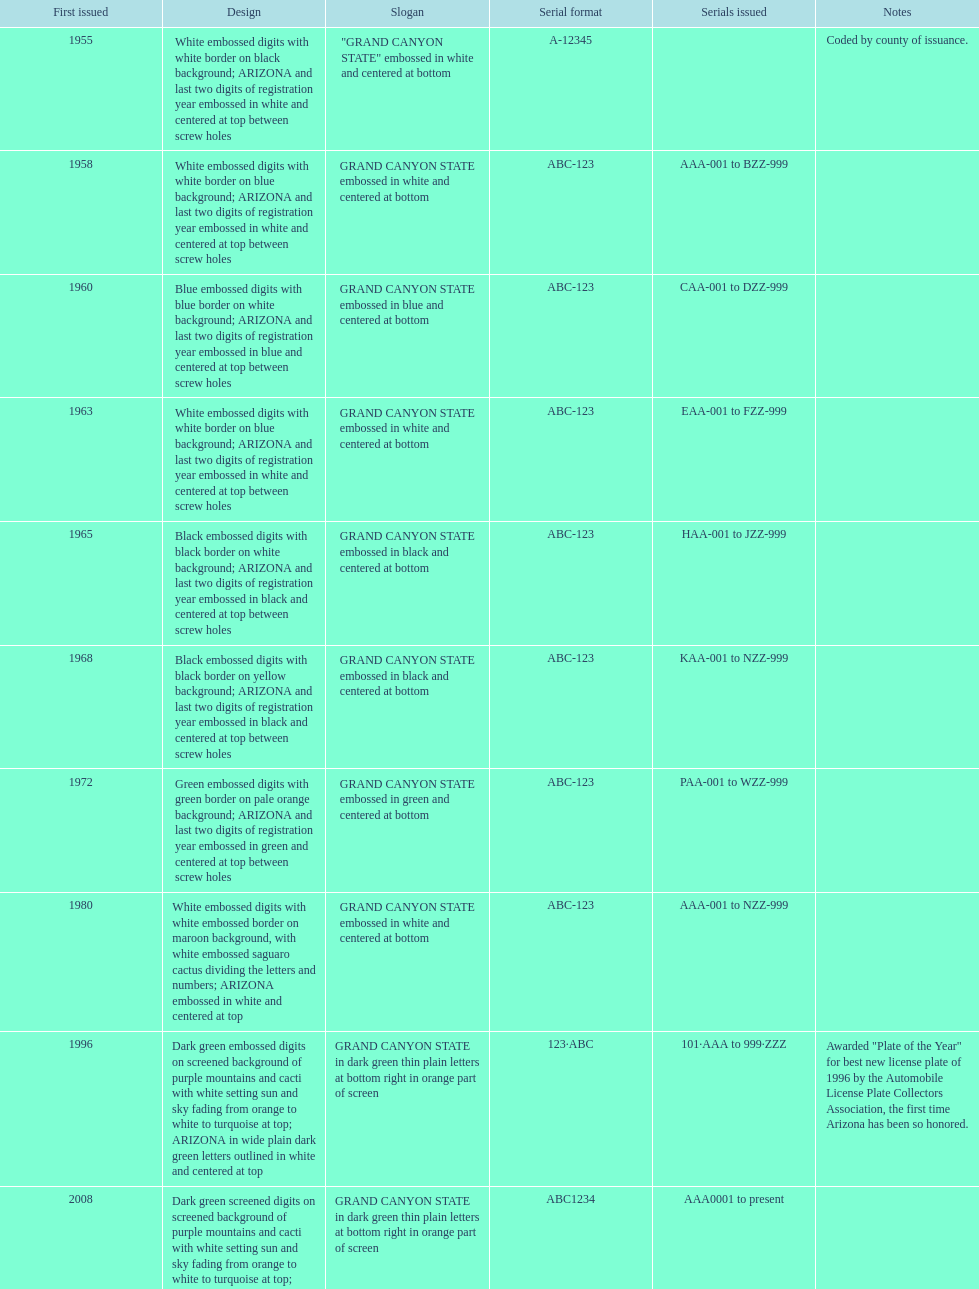What year did the first arizona license plate come into existence? 1955. 